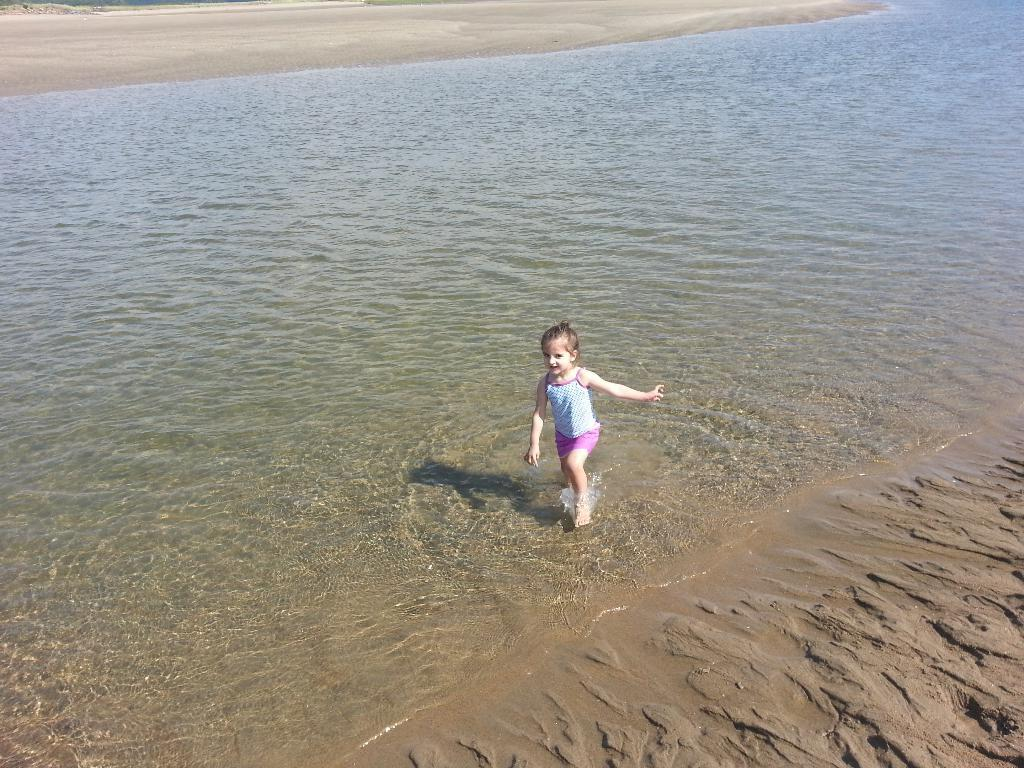What is the primary element present in the image? There is water in the image. What is the child doing in the water? A child is standing in the water. What type of terrain is visible in the image? There is sand in the image. What can be seen in the background of the image? The ground is visible in the background of the image. What type of chalk is the child using in the image? There is no chalk present in the image. What event is taking place in the image? There is no indication of an event taking place in the image. 